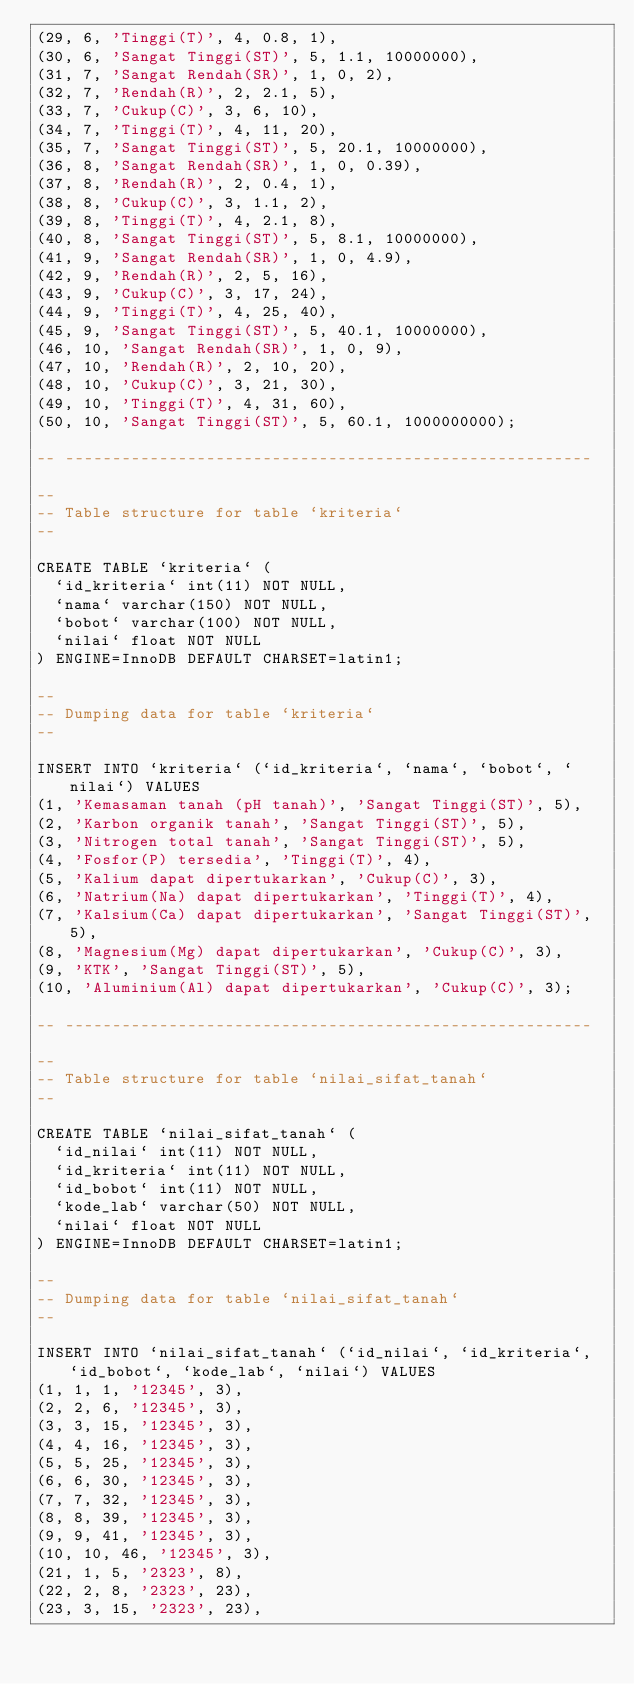<code> <loc_0><loc_0><loc_500><loc_500><_SQL_>(29, 6, 'Tinggi(T)', 4, 0.8, 1),
(30, 6, 'Sangat Tinggi(ST)', 5, 1.1, 10000000),
(31, 7, 'Sangat Rendah(SR)', 1, 0, 2),
(32, 7, 'Rendah(R)', 2, 2.1, 5),
(33, 7, 'Cukup(C)', 3, 6, 10),
(34, 7, 'Tinggi(T)', 4, 11, 20),
(35, 7, 'Sangat Tinggi(ST)', 5, 20.1, 10000000),
(36, 8, 'Sangat Rendah(SR)', 1, 0, 0.39),
(37, 8, 'Rendah(R)', 2, 0.4, 1),
(38, 8, 'Cukup(C)', 3, 1.1, 2),
(39, 8, 'Tinggi(T)', 4, 2.1, 8),
(40, 8, 'Sangat Tinggi(ST)', 5, 8.1, 10000000),
(41, 9, 'Sangat Rendah(SR)', 1, 0, 4.9),
(42, 9, 'Rendah(R)', 2, 5, 16),
(43, 9, 'Cukup(C)', 3, 17, 24),
(44, 9, 'Tinggi(T)', 4, 25, 40),
(45, 9, 'Sangat Tinggi(ST)', 5, 40.1, 10000000),
(46, 10, 'Sangat Rendah(SR)', 1, 0, 9),
(47, 10, 'Rendah(R)', 2, 10, 20),
(48, 10, 'Cukup(C)', 3, 21, 30),
(49, 10, 'Tinggi(T)', 4, 31, 60),
(50, 10, 'Sangat Tinggi(ST)', 5, 60.1, 1000000000);

-- --------------------------------------------------------

--
-- Table structure for table `kriteria`
--

CREATE TABLE `kriteria` (
  `id_kriteria` int(11) NOT NULL,
  `nama` varchar(150) NOT NULL,
  `bobot` varchar(100) NOT NULL,
  `nilai` float NOT NULL
) ENGINE=InnoDB DEFAULT CHARSET=latin1;

--
-- Dumping data for table `kriteria`
--

INSERT INTO `kriteria` (`id_kriteria`, `nama`, `bobot`, `nilai`) VALUES
(1, 'Kemasaman tanah (pH tanah)', 'Sangat Tinggi(ST)', 5),
(2, 'Karbon organik tanah', 'Sangat Tinggi(ST)', 5),
(3, 'Nitrogen total tanah', 'Sangat Tinggi(ST)', 5),
(4, 'Fosfor(P) tersedia', 'Tinggi(T)', 4),
(5, 'Kalium dapat dipertukarkan', 'Cukup(C)', 3),
(6, 'Natrium(Na) dapat dipertukarkan', 'Tinggi(T)', 4),
(7, 'Kalsium(Ca) dapat dipertukarkan', 'Sangat Tinggi(ST)', 5),
(8, 'Magnesium(Mg) dapat dipertukarkan', 'Cukup(C)', 3),
(9, 'KTK', 'Sangat Tinggi(ST)', 5),
(10, 'Aluminium(Al) dapat dipertukarkan', 'Cukup(C)', 3);

-- --------------------------------------------------------

--
-- Table structure for table `nilai_sifat_tanah`
--

CREATE TABLE `nilai_sifat_tanah` (
  `id_nilai` int(11) NOT NULL,
  `id_kriteria` int(11) NOT NULL,
  `id_bobot` int(11) NOT NULL,
  `kode_lab` varchar(50) NOT NULL,
  `nilai` float NOT NULL
) ENGINE=InnoDB DEFAULT CHARSET=latin1;

--
-- Dumping data for table `nilai_sifat_tanah`
--

INSERT INTO `nilai_sifat_tanah` (`id_nilai`, `id_kriteria`, `id_bobot`, `kode_lab`, `nilai`) VALUES
(1, 1, 1, '12345', 3),
(2, 2, 6, '12345', 3),
(3, 3, 15, '12345', 3),
(4, 4, 16, '12345', 3),
(5, 5, 25, '12345', 3),
(6, 6, 30, '12345', 3),
(7, 7, 32, '12345', 3),
(8, 8, 39, '12345', 3),
(9, 9, 41, '12345', 3),
(10, 10, 46, '12345', 3),
(21, 1, 5, '2323', 8),
(22, 2, 8, '2323', 23),
(23, 3, 15, '2323', 23),</code> 